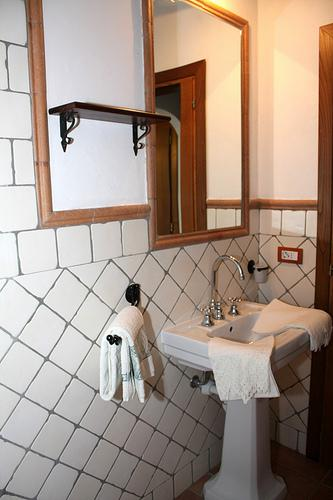Question: what color are the tiles?
Choices:
A. Black.
B. Red.
C. Blue.
D. White.
Answer with the letter. Answer: D Question: how many towels are in the picture?
Choices:
A. Three.
B. One.
C. Two.
D. Four.
Answer with the letter. Answer: A Question: where is the mirror?
Choices:
A. Behind the door.
B. Beside the toilet.
C. Above the sink.
D. In the closet.
Answer with the letter. Answer: C Question: what material is the trim?
Choices:
A. Plastic.
B. Velvet.
C. Tile.
D. Wood.
Answer with the letter. Answer: D Question: what color is the faucet?
Choices:
A. Silver.
B. Gray.
C. Black.
D. White.
Answer with the letter. Answer: A Question: where was the picture taken?
Choices:
A. Beach.
B. In a bathroom.
C. Ski lodge.
D. Castle.
Answer with the letter. Answer: B Question: where was the picture taken?
Choices:
A. Under dining room table.
B. In kitchen sink.
C. Bathroom.
D. Behind sofa.
Answer with the letter. Answer: C 